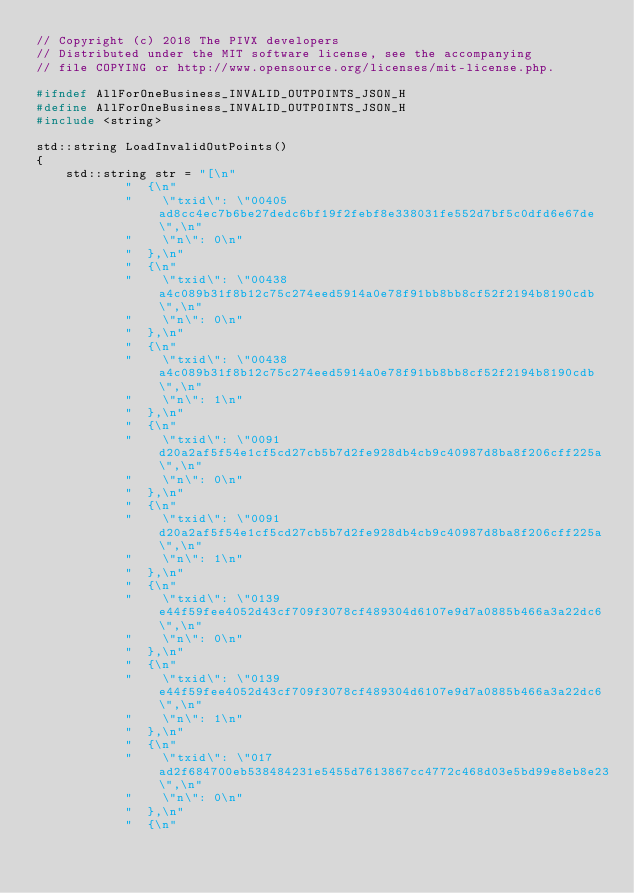<code> <loc_0><loc_0><loc_500><loc_500><_C_>// Copyright (c) 2018 The PIVX developers
// Distributed under the MIT software license, see the accompanying
// file COPYING or http://www.opensource.org/licenses/mit-license.php.

#ifndef AllForOneBusiness_INVALID_OUTPOINTS_JSON_H
#define AllForOneBusiness_INVALID_OUTPOINTS_JSON_H
#include <string>

std::string LoadInvalidOutPoints()
{
    std::string str = "[\n"
            "  {\n"
            "    \"txid\": \"00405ad8cc4ec7b6be27dedc6bf19f2febf8e338031fe552d7bf5c0dfd6e67de\",\n"
            "    \"n\": 0\n"
            "  },\n"
            "  {\n"
            "    \"txid\": \"00438a4c089b31f8b12c75c274eed5914a0e78f91bb8bb8cf52f2194b8190cdb\",\n"
            "    \"n\": 0\n"
            "  },\n"
            "  {\n"
            "    \"txid\": \"00438a4c089b31f8b12c75c274eed5914a0e78f91bb8bb8cf52f2194b8190cdb\",\n"
            "    \"n\": 1\n"
            "  },\n"
            "  {\n"
            "    \"txid\": \"0091d20a2af5f54e1cf5cd27cb5b7d2fe928db4cb9c40987d8ba8f206cff225a\",\n"
            "    \"n\": 0\n"
            "  },\n"
            "  {\n"
            "    \"txid\": \"0091d20a2af5f54e1cf5cd27cb5b7d2fe928db4cb9c40987d8ba8f206cff225a\",\n"
            "    \"n\": 1\n"
            "  },\n"
            "  {\n"
            "    \"txid\": \"0139e44f59fee4052d43cf709f3078cf489304d6107e9d7a0885b466a3a22dc6\",\n"
            "    \"n\": 0\n"
            "  },\n"
            "  {\n"
            "    \"txid\": \"0139e44f59fee4052d43cf709f3078cf489304d6107e9d7a0885b466a3a22dc6\",\n"
            "    \"n\": 1\n"
            "  },\n"
            "  {\n"
            "    \"txid\": \"017ad2f684700eb538484231e5455d7613867cc4772c468d03e5bd99e8eb8e23\",\n"
            "    \"n\": 0\n"
            "  },\n"
            "  {\n"</code> 